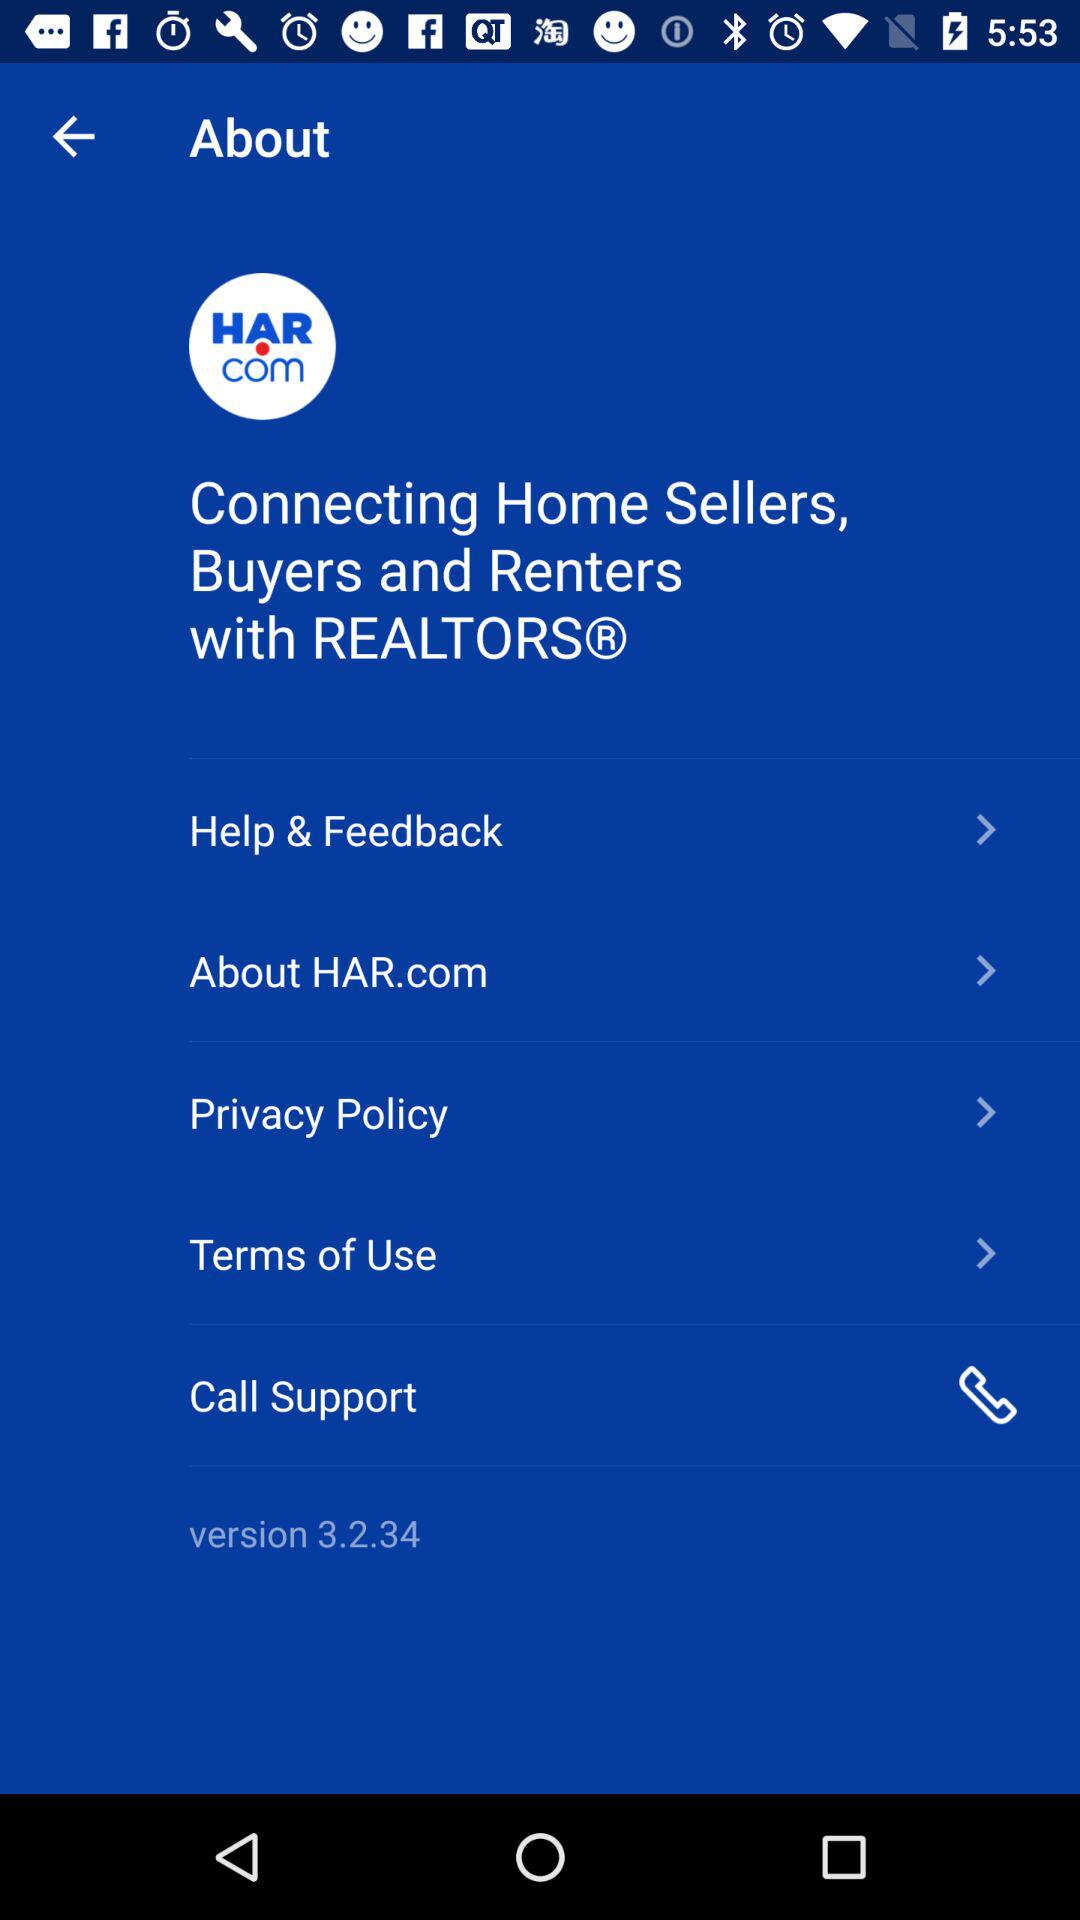What is the version of "HAR.com"? The version of "HAR.com" is 3.2.34. 